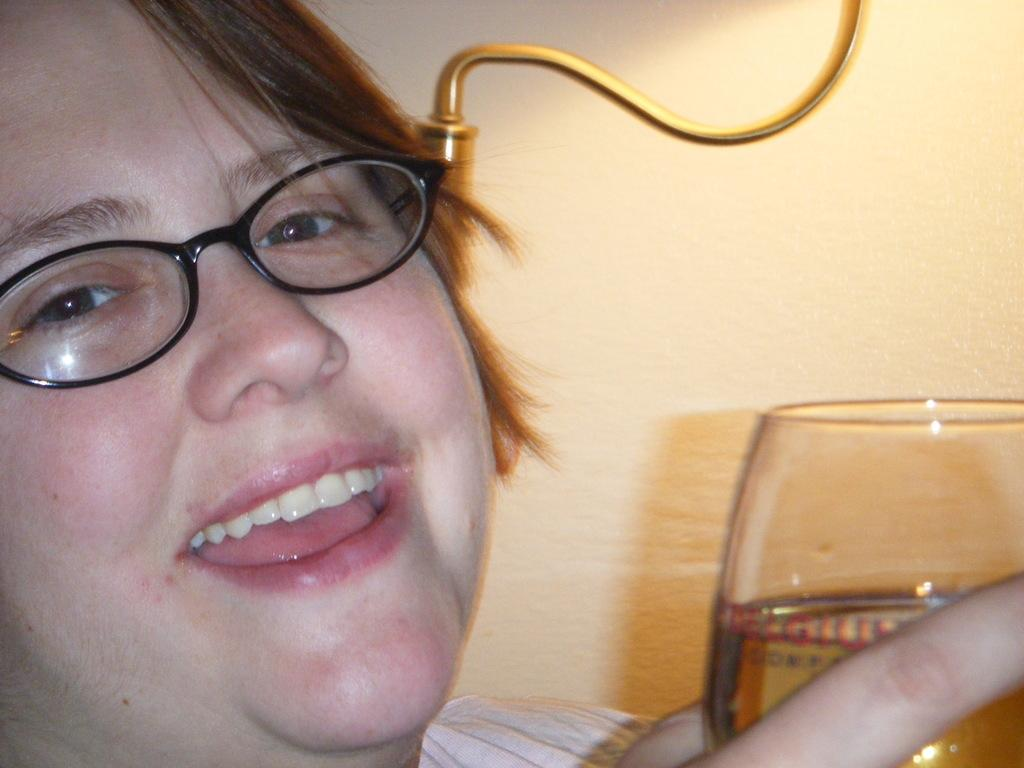Who is the main subject in the image? There is a lady in the image. What is the lady wearing? The lady is wearing glasses. What expression does the lady have? The lady is smiling. What is the lady holding in the image? The lady is holding a glass. What can be seen in the background of the image? There is a wall in the background of the image. How many jellyfish are swimming in the glass held by the lady in the image? There are no jellyfish present in the image; the lady is holding a glass, but it is not filled with jellyfish. 